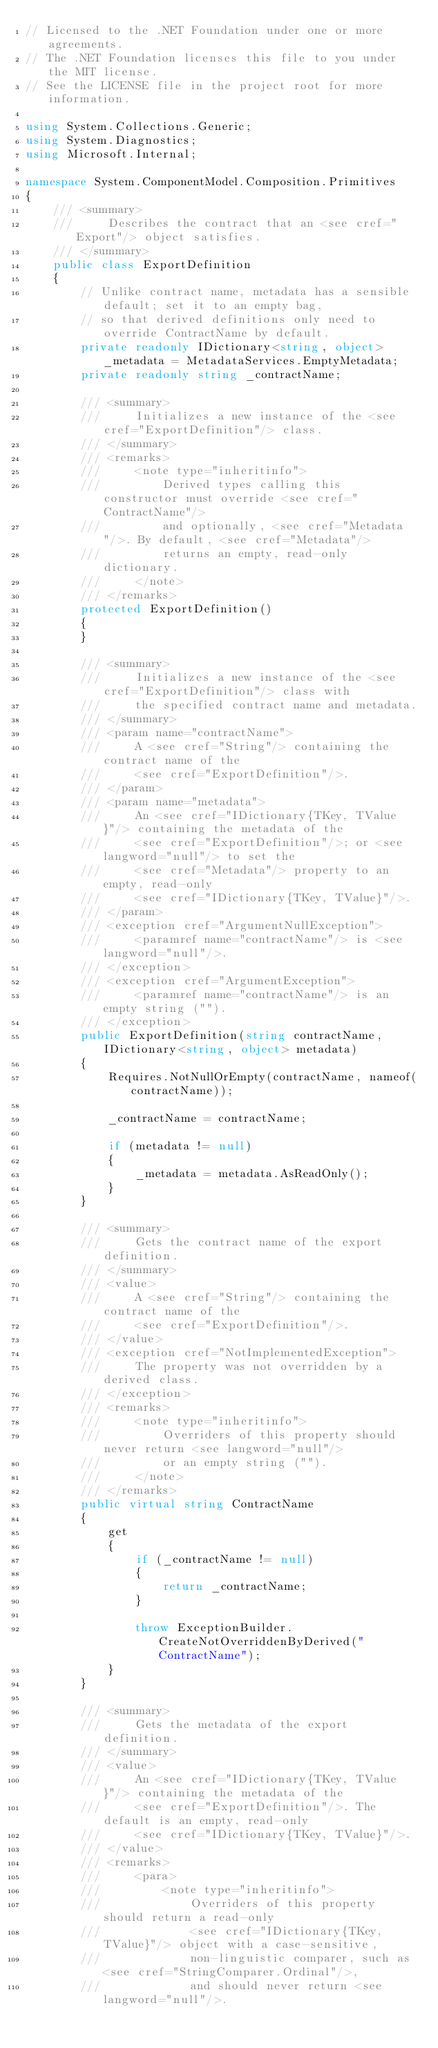Convert code to text. <code><loc_0><loc_0><loc_500><loc_500><_C#_>// Licensed to the .NET Foundation under one or more agreements.
// The .NET Foundation licenses this file to you under the MIT license.
// See the LICENSE file in the project root for more information.

using System.Collections.Generic;
using System.Diagnostics;
using Microsoft.Internal;

namespace System.ComponentModel.Composition.Primitives
{
    /// <summary>
    ///     Describes the contract that an <see cref="Export"/> object satisfies.
    /// </summary>
    public class ExportDefinition
    {
        // Unlike contract name, metadata has a sensible default; set it to an empty bag, 
        // so that derived definitions only need to override ContractName by default.
        private readonly IDictionary<string, object> _metadata = MetadataServices.EmptyMetadata;
        private readonly string _contractName;

        /// <summary>
        ///     Initializes a new instance of the <see cref="ExportDefinition"/> class.
        /// </summary>
        /// <remarks>
        ///     <note type="inheritinfo">
        ///         Derived types calling this constructor must override <see cref="ContractName"/>
        ///         and optionally, <see cref="Metadata"/>. By default, <see cref="Metadata"/>
        ///         returns an empty, read-only dictionary.
        ///     </note>
        /// </remarks>
        protected ExportDefinition()
        {
        }

        /// <summary>
        ///     Initializes a new instance of the <see cref="ExportDefinition"/> class with 
        ///     the specified contract name and metadata.
        /// </summary>
        /// <param name="contractName">
        ///     A <see cref="String"/> containing the contract name of the 
        ///     <see cref="ExportDefinition"/>.
        /// </param>
        /// <param name="metadata">
        ///     An <see cref="IDictionary{TKey, TValue}"/> containing the metadata of the 
        ///     <see cref="ExportDefinition"/>; or <see langword="null"/> to set the 
        ///     <see cref="Metadata"/> property to an empty, read-only 
        ///     <see cref="IDictionary{TKey, TValue}"/>.
        /// </param>
        /// <exception cref="ArgumentNullException">
        ///     <paramref name="contractName"/> is <see langword="null"/>.
        /// </exception>
        /// <exception cref="ArgumentException">
        ///     <paramref name="contractName"/> is an empty string ("").
        /// </exception>
        public ExportDefinition(string contractName, IDictionary<string, object> metadata)
        {
            Requires.NotNullOrEmpty(contractName, nameof(contractName));

            _contractName = contractName;

            if (metadata != null)
            {
                _metadata = metadata.AsReadOnly();
            }
        }

        /// <summary>
        ///     Gets the contract name of the export definition.
        /// </summary>
        /// <value>
        ///     A <see cref="String"/> containing the contract name of the 
        ///     <see cref="ExportDefinition"/>.
        /// </value>
        /// <exception cref="NotImplementedException">
        ///     The property was not overridden by a derived class.
        /// </exception>
        /// <remarks>
        ///     <note type="inheritinfo">
        ///         Overriders of this property should never return <see langword="null"/> 
        ///         or an empty string ("").
        ///     </note>
        /// </remarks>
        public virtual string ContractName
        {
            get 
            {
                if (_contractName != null)
                {
                    return _contractName;
                }

                throw ExceptionBuilder.CreateNotOverriddenByDerived("ContractName");
            }
        }

        /// <summary>
        ///     Gets the metadata of the export definition.
        /// </summary>
        /// <value>
        ///     An <see cref="IDictionary{TKey, TValue}"/> containing the metadata of the 
        ///     <see cref="ExportDefinition"/>. The default is an empty, read-only
        ///     <see cref="IDictionary{TKey, TValue}"/>.
        /// </value>
        /// <remarks>
        ///     <para>
        ///         <note type="inheritinfo">
        ///             Overriders of this property should return a read-only
        ///             <see cref="IDictionary{TKey, TValue}"/> object with a case-sensitive, 
        ///             non-linguistic comparer, such as <see cref="StringComparer.Ordinal"/>, 
        ///             and should never return <see langword="null"/>.</code> 